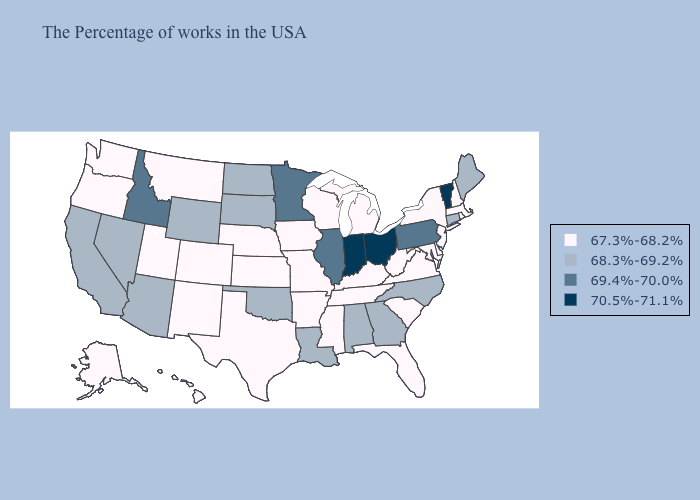What is the lowest value in the Northeast?
Concise answer only. 67.3%-68.2%. Among the states that border Georgia , does Alabama have the highest value?
Short answer required. Yes. Does Wisconsin have the highest value in the USA?
Short answer required. No. Name the states that have a value in the range 68.3%-69.2%?
Be succinct. Maine, Connecticut, North Carolina, Georgia, Alabama, Louisiana, Oklahoma, South Dakota, North Dakota, Wyoming, Arizona, Nevada, California. Among the states that border Colorado , which have the highest value?
Give a very brief answer. Oklahoma, Wyoming, Arizona. What is the highest value in the MidWest ?
Concise answer only. 70.5%-71.1%. Does the first symbol in the legend represent the smallest category?
Write a very short answer. Yes. What is the lowest value in states that border Tennessee?
Be succinct. 67.3%-68.2%. Which states have the lowest value in the USA?
Keep it brief. Massachusetts, Rhode Island, New Hampshire, New York, New Jersey, Delaware, Maryland, Virginia, South Carolina, West Virginia, Florida, Michigan, Kentucky, Tennessee, Wisconsin, Mississippi, Missouri, Arkansas, Iowa, Kansas, Nebraska, Texas, Colorado, New Mexico, Utah, Montana, Washington, Oregon, Alaska, Hawaii. What is the highest value in the MidWest ?
Quick response, please. 70.5%-71.1%. What is the value of Florida?
Short answer required. 67.3%-68.2%. What is the value of New Hampshire?
Concise answer only. 67.3%-68.2%. What is the value of West Virginia?
Answer briefly. 67.3%-68.2%. What is the value of Kentucky?
Quick response, please. 67.3%-68.2%. Does Tennessee have a lower value than Wisconsin?
Keep it brief. No. 